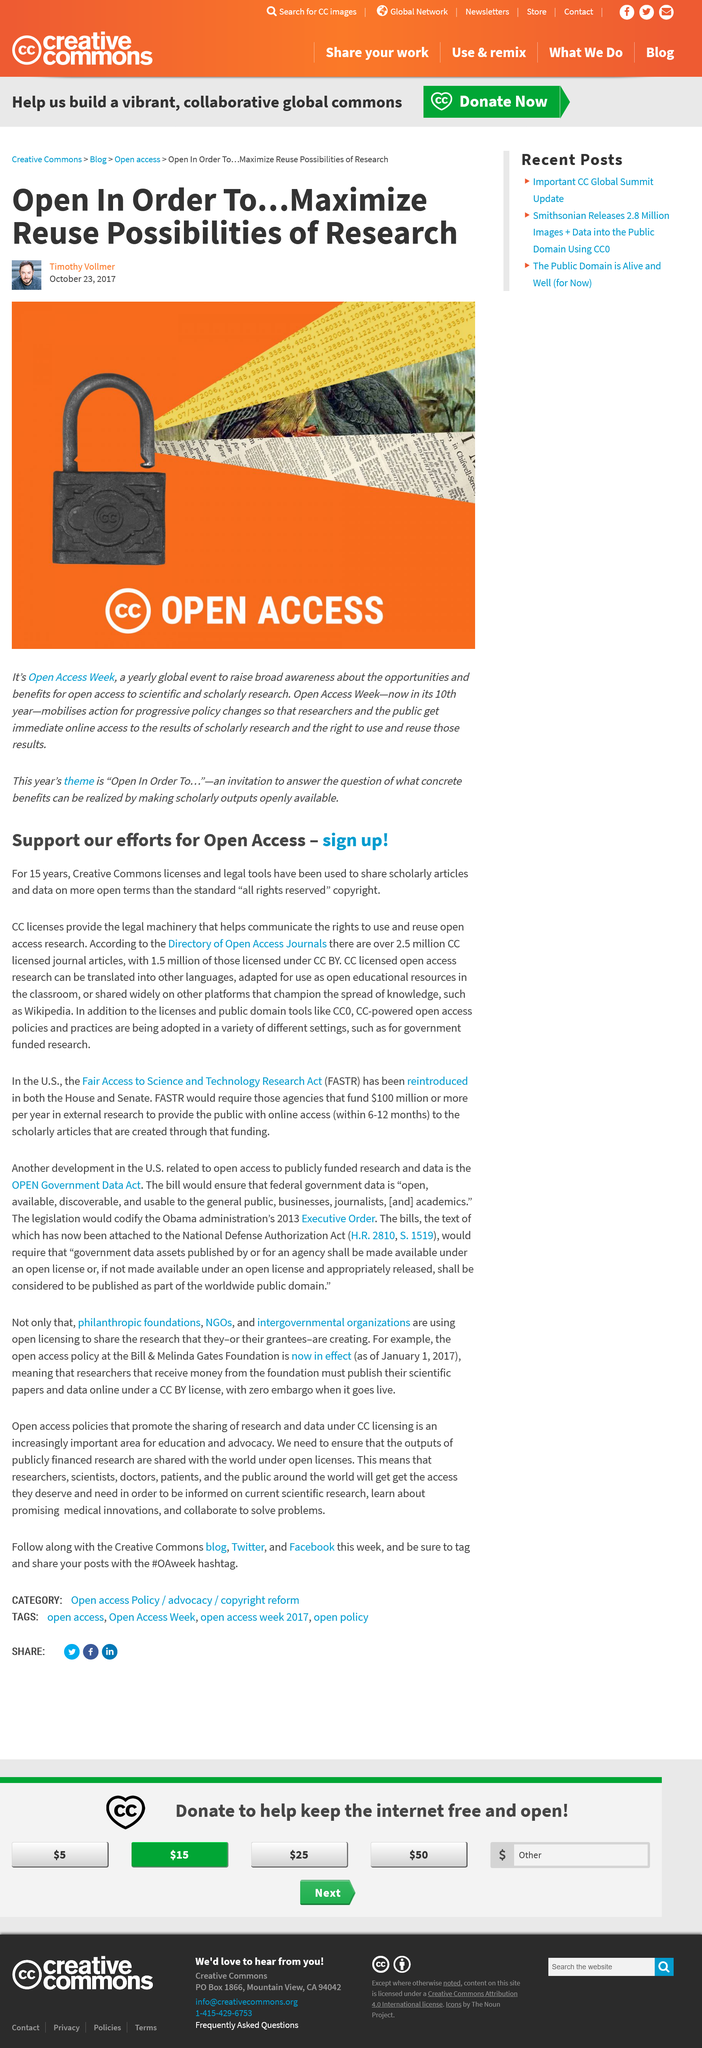Outline some significant characteristics in this image. Creative Commons was created 15 years ago. There are over 2.5 million CC licensed journal articles available. You are allowed to translate, adapt for use in classrooms, or share on educational platforms such as Wikipedia, CC licensed open access research. In October, Open Access Week is held. Open Access Week is held annually. 